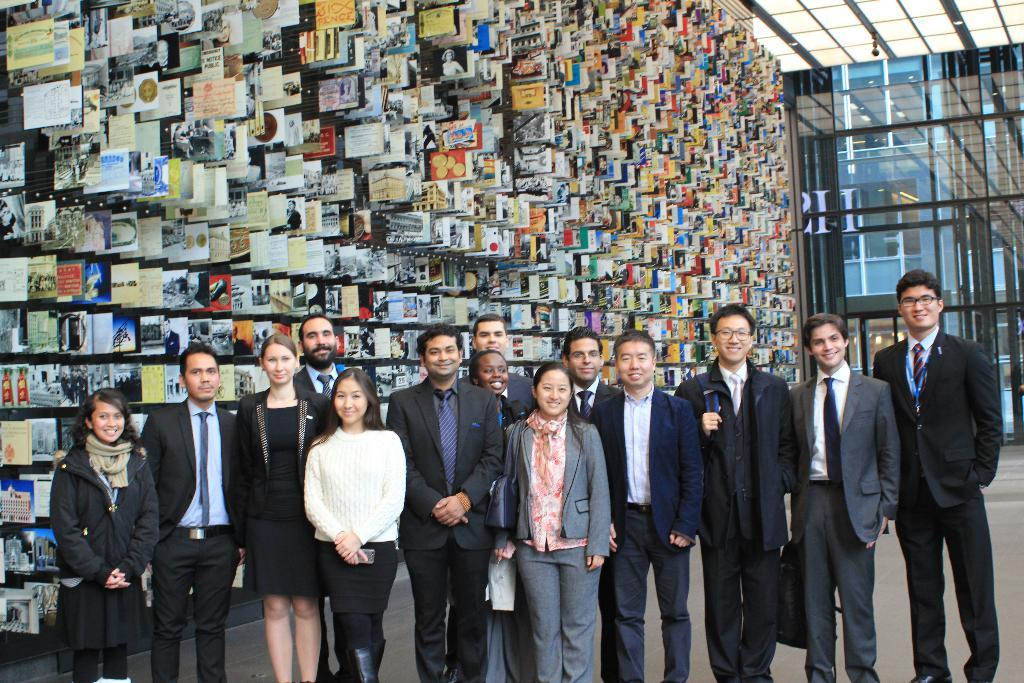How many people are in the image? There is a group of people in the image. What are the people in the image doing? The people are standing and smiling. Where is the group of people located? The group of people is inside a building. What can be seen on the wall in the background? There are photos attached to the wall in the background. What is visible in the background that provides light? There are lights visible in the background. What type of soup is being served in the image? There is no soup present in the image. Can you provide an example of a receipt that might be related to the people in the image? There is no receipt present in the image, so it is not possible to provide an example related to the people in the image. 